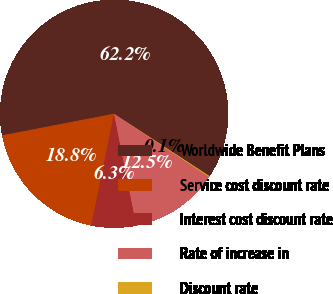Convert chart. <chart><loc_0><loc_0><loc_500><loc_500><pie_chart><fcel>Worldwide Benefit Plans<fcel>Service cost discount rate<fcel>Interest cost discount rate<fcel>Rate of increase in<fcel>Discount rate<nl><fcel>62.25%<fcel>18.76%<fcel>6.33%<fcel>12.54%<fcel>0.12%<nl></chart> 